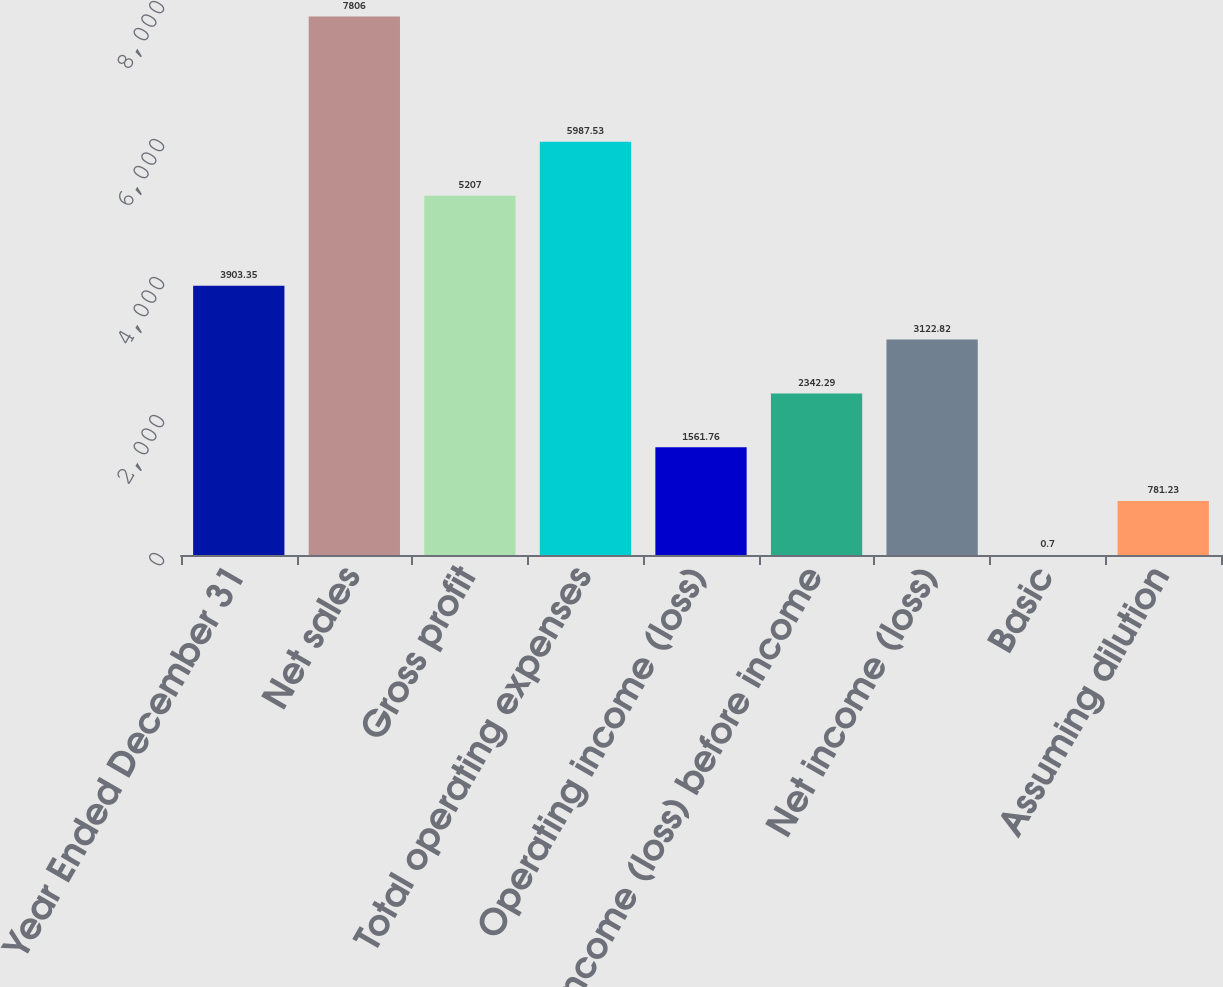<chart> <loc_0><loc_0><loc_500><loc_500><bar_chart><fcel>Year Ended December 31<fcel>Net sales<fcel>Gross profit<fcel>Total operating expenses<fcel>Operating income (loss)<fcel>Income (loss) before income<fcel>Net income (loss)<fcel>Basic<fcel>Assuming dilution<nl><fcel>3903.35<fcel>7806<fcel>5207<fcel>5987.53<fcel>1561.76<fcel>2342.29<fcel>3122.82<fcel>0.7<fcel>781.23<nl></chart> 